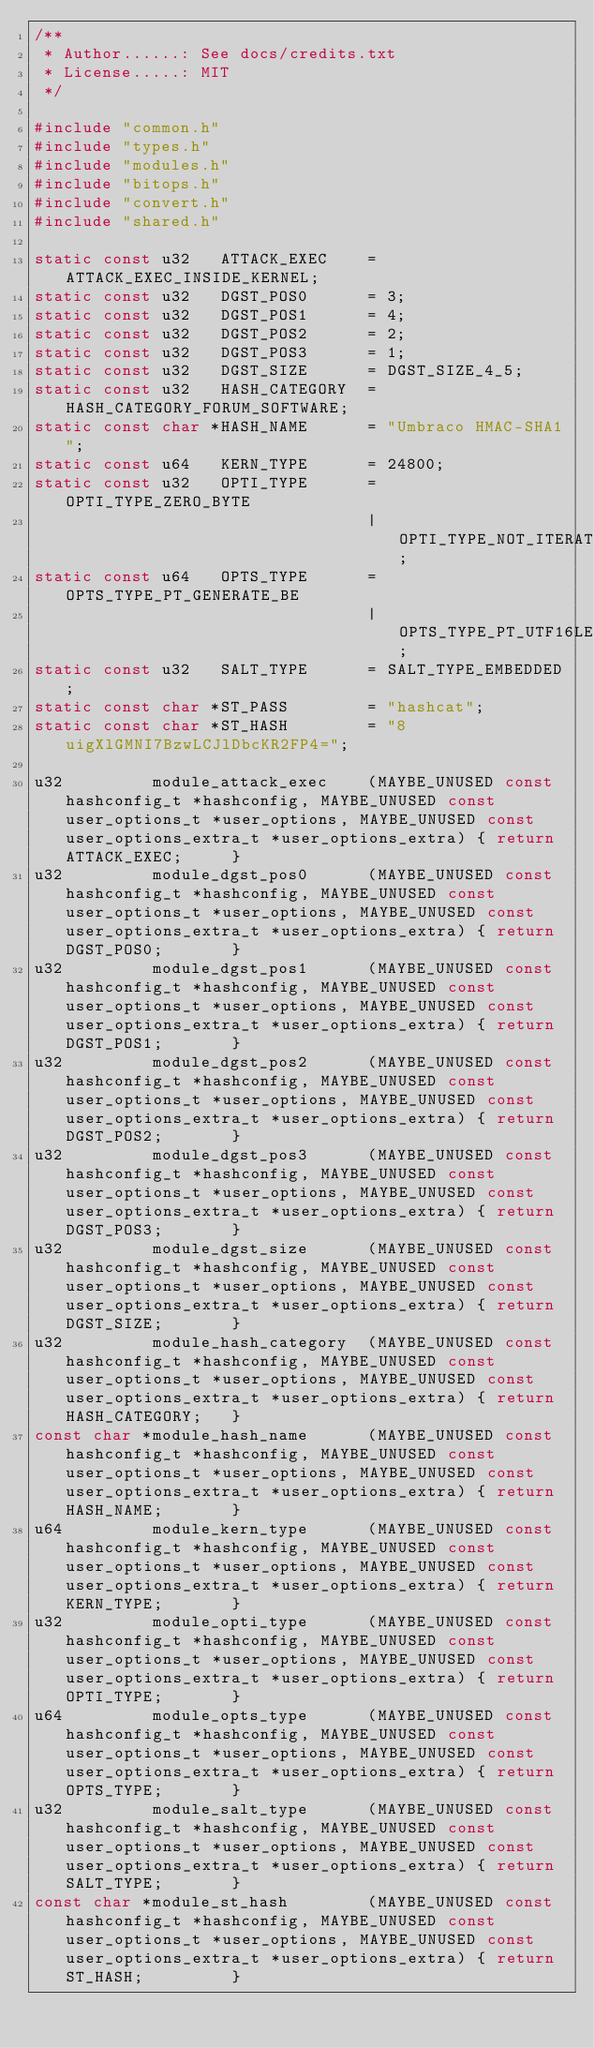<code> <loc_0><loc_0><loc_500><loc_500><_C_>/**
 * Author......: See docs/credits.txt
 * License.....: MIT
 */

#include "common.h"
#include "types.h"
#include "modules.h"
#include "bitops.h"
#include "convert.h"
#include "shared.h"

static const u32   ATTACK_EXEC    = ATTACK_EXEC_INSIDE_KERNEL;
static const u32   DGST_POS0      = 3;
static const u32   DGST_POS1      = 4;
static const u32   DGST_POS2      = 2;
static const u32   DGST_POS3      = 1;
static const u32   DGST_SIZE      = DGST_SIZE_4_5;
static const u32   HASH_CATEGORY  = HASH_CATEGORY_FORUM_SOFTWARE;
static const char *HASH_NAME      = "Umbraco HMAC-SHA1";
static const u64   KERN_TYPE      = 24800;
static const u32   OPTI_TYPE      = OPTI_TYPE_ZERO_BYTE
                                  | OPTI_TYPE_NOT_ITERATED;
static const u64   OPTS_TYPE      = OPTS_TYPE_PT_GENERATE_BE
                                  | OPTS_TYPE_PT_UTF16LE;
static const u32   SALT_TYPE      = SALT_TYPE_EMBEDDED;
static const char *ST_PASS        = "hashcat";
static const char *ST_HASH        = "8uigXlGMNI7BzwLCJlDbcKR2FP4=";

u32         module_attack_exec    (MAYBE_UNUSED const hashconfig_t *hashconfig, MAYBE_UNUSED const user_options_t *user_options, MAYBE_UNUSED const user_options_extra_t *user_options_extra) { return ATTACK_EXEC;     }
u32         module_dgst_pos0      (MAYBE_UNUSED const hashconfig_t *hashconfig, MAYBE_UNUSED const user_options_t *user_options, MAYBE_UNUSED const user_options_extra_t *user_options_extra) { return DGST_POS0;       }
u32         module_dgst_pos1      (MAYBE_UNUSED const hashconfig_t *hashconfig, MAYBE_UNUSED const user_options_t *user_options, MAYBE_UNUSED const user_options_extra_t *user_options_extra) { return DGST_POS1;       }
u32         module_dgst_pos2      (MAYBE_UNUSED const hashconfig_t *hashconfig, MAYBE_UNUSED const user_options_t *user_options, MAYBE_UNUSED const user_options_extra_t *user_options_extra) { return DGST_POS2;       }
u32         module_dgst_pos3      (MAYBE_UNUSED const hashconfig_t *hashconfig, MAYBE_UNUSED const user_options_t *user_options, MAYBE_UNUSED const user_options_extra_t *user_options_extra) { return DGST_POS3;       }
u32         module_dgst_size      (MAYBE_UNUSED const hashconfig_t *hashconfig, MAYBE_UNUSED const user_options_t *user_options, MAYBE_UNUSED const user_options_extra_t *user_options_extra) { return DGST_SIZE;       }
u32         module_hash_category  (MAYBE_UNUSED const hashconfig_t *hashconfig, MAYBE_UNUSED const user_options_t *user_options, MAYBE_UNUSED const user_options_extra_t *user_options_extra) { return HASH_CATEGORY;   }
const char *module_hash_name      (MAYBE_UNUSED const hashconfig_t *hashconfig, MAYBE_UNUSED const user_options_t *user_options, MAYBE_UNUSED const user_options_extra_t *user_options_extra) { return HASH_NAME;       }
u64         module_kern_type      (MAYBE_UNUSED const hashconfig_t *hashconfig, MAYBE_UNUSED const user_options_t *user_options, MAYBE_UNUSED const user_options_extra_t *user_options_extra) { return KERN_TYPE;       }
u32         module_opti_type      (MAYBE_UNUSED const hashconfig_t *hashconfig, MAYBE_UNUSED const user_options_t *user_options, MAYBE_UNUSED const user_options_extra_t *user_options_extra) { return OPTI_TYPE;       }
u64         module_opts_type      (MAYBE_UNUSED const hashconfig_t *hashconfig, MAYBE_UNUSED const user_options_t *user_options, MAYBE_UNUSED const user_options_extra_t *user_options_extra) { return OPTS_TYPE;       }
u32         module_salt_type      (MAYBE_UNUSED const hashconfig_t *hashconfig, MAYBE_UNUSED const user_options_t *user_options, MAYBE_UNUSED const user_options_extra_t *user_options_extra) { return SALT_TYPE;       }
const char *module_st_hash        (MAYBE_UNUSED const hashconfig_t *hashconfig, MAYBE_UNUSED const user_options_t *user_options, MAYBE_UNUSED const user_options_extra_t *user_options_extra) { return ST_HASH;         }</code> 